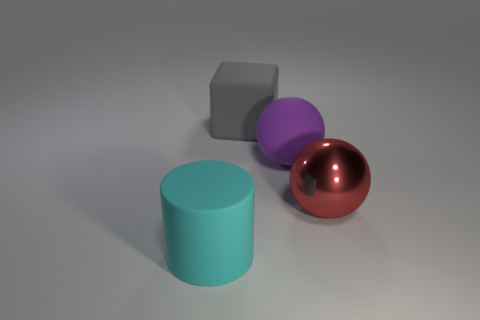Add 2 red metallic balls. How many objects exist? 6 Subtract all cylinders. How many objects are left? 3 Add 4 cylinders. How many cylinders are left? 5 Add 4 small brown blocks. How many small brown blocks exist? 4 Subtract 0 gray balls. How many objects are left? 4 Subtract all green cylinders. Subtract all yellow balls. How many cylinders are left? 1 Subtract all gray rubber cubes. Subtract all large matte balls. How many objects are left? 2 